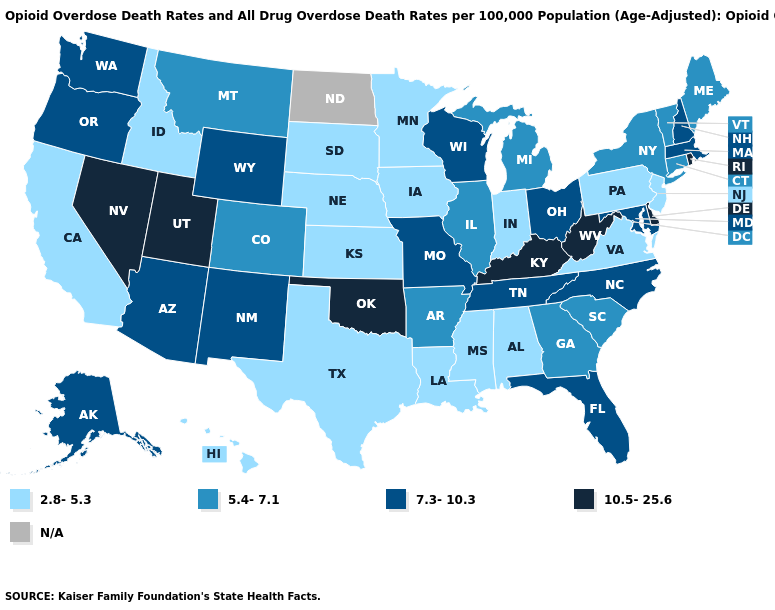What is the highest value in the USA?
Concise answer only. 10.5-25.6. Is the legend a continuous bar?
Write a very short answer. No. Which states have the lowest value in the USA?
Short answer required. Alabama, California, Hawaii, Idaho, Indiana, Iowa, Kansas, Louisiana, Minnesota, Mississippi, Nebraska, New Jersey, Pennsylvania, South Dakota, Texas, Virginia. Does the map have missing data?
Quick response, please. Yes. What is the highest value in the West ?
Answer briefly. 10.5-25.6. Name the states that have a value in the range 2.8-5.3?
Concise answer only. Alabama, California, Hawaii, Idaho, Indiana, Iowa, Kansas, Louisiana, Minnesota, Mississippi, Nebraska, New Jersey, Pennsylvania, South Dakota, Texas, Virginia. Which states have the lowest value in the USA?
Give a very brief answer. Alabama, California, Hawaii, Idaho, Indiana, Iowa, Kansas, Louisiana, Minnesota, Mississippi, Nebraska, New Jersey, Pennsylvania, South Dakota, Texas, Virginia. Which states have the lowest value in the South?
Quick response, please. Alabama, Louisiana, Mississippi, Texas, Virginia. What is the lowest value in the MidWest?
Write a very short answer. 2.8-5.3. What is the highest value in the USA?
Answer briefly. 10.5-25.6. Among the states that border Utah , which have the highest value?
Short answer required. Nevada. Name the states that have a value in the range N/A?
Be succinct. North Dakota. What is the lowest value in states that border Florida?
Quick response, please. 2.8-5.3. 